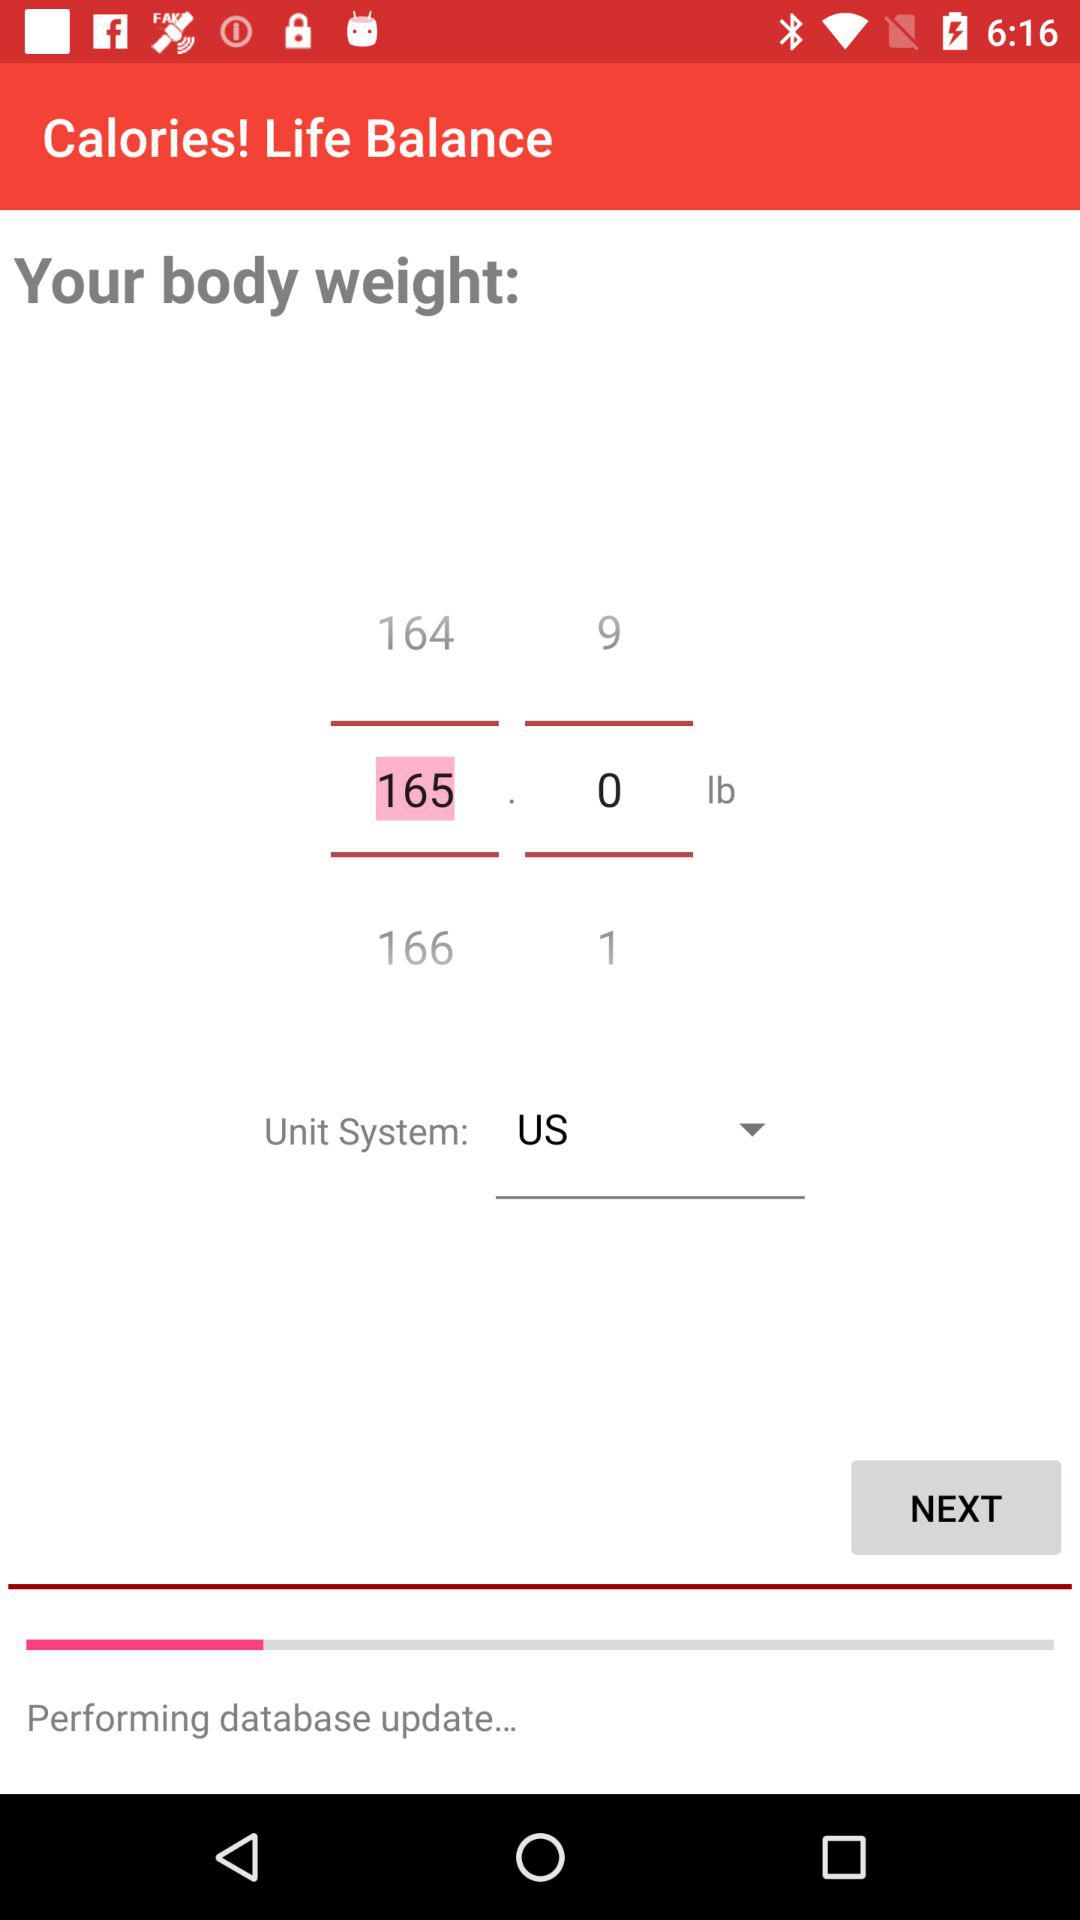What is the chosen unit system? The chosen unit system is "US". 